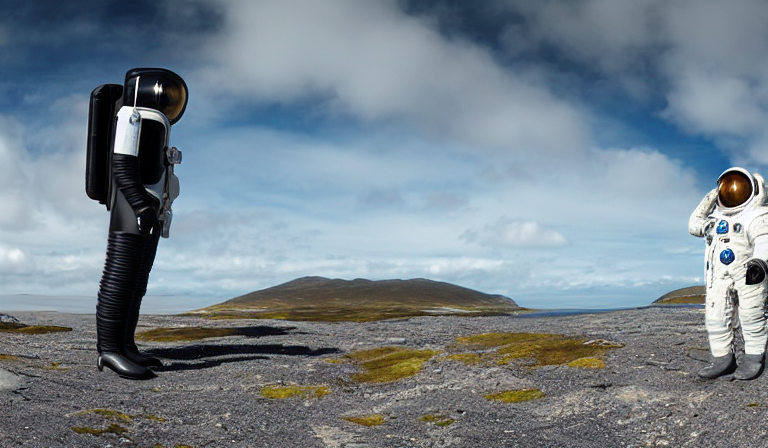What is the lighting condition in this image? The image is well-lit with a bright scene, where the sunlight appears to evenly illuminate the landscape and the subjects within, namely the astronaut and the unusual figure resembling an astronaut's torso and helmet with a camera-like structure in place of the body. 